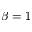<formula> <loc_0><loc_0><loc_500><loc_500>\beta = 1</formula> 